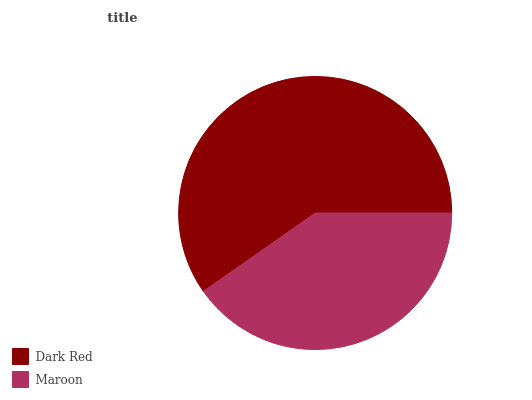Is Maroon the minimum?
Answer yes or no. Yes. Is Dark Red the maximum?
Answer yes or no. Yes. Is Maroon the maximum?
Answer yes or no. No. Is Dark Red greater than Maroon?
Answer yes or no. Yes. Is Maroon less than Dark Red?
Answer yes or no. Yes. Is Maroon greater than Dark Red?
Answer yes or no. No. Is Dark Red less than Maroon?
Answer yes or no. No. Is Dark Red the high median?
Answer yes or no. Yes. Is Maroon the low median?
Answer yes or no. Yes. Is Maroon the high median?
Answer yes or no. No. Is Dark Red the low median?
Answer yes or no. No. 